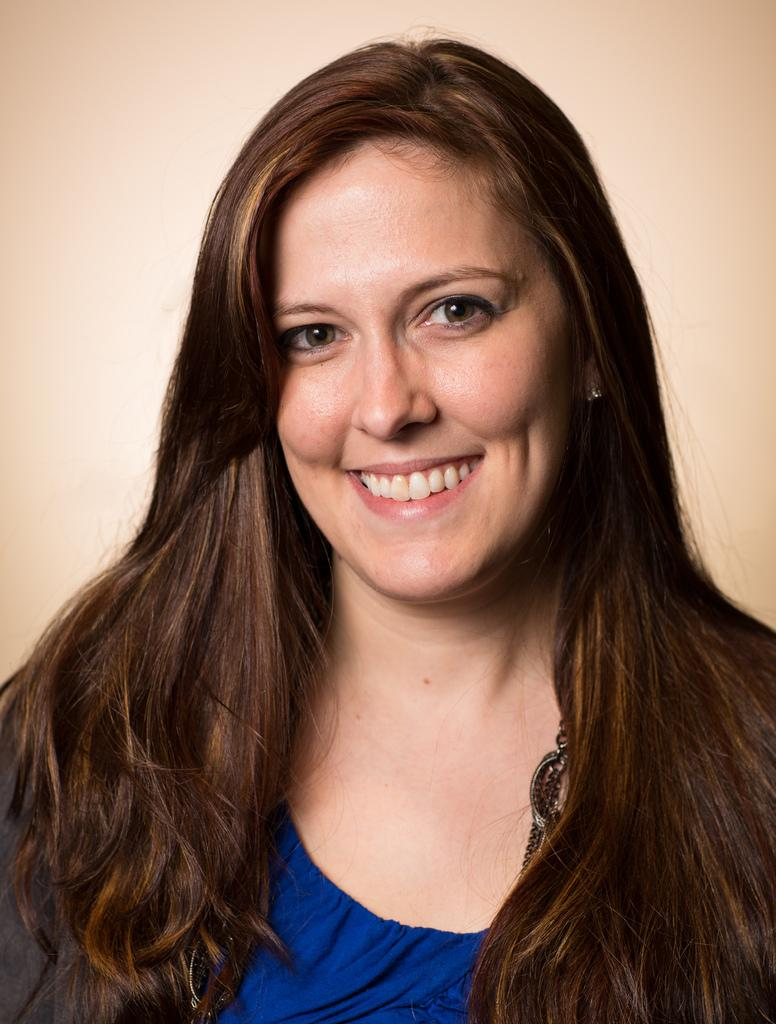Who is present in the image? There is a woman in the image. What expression does the woman have? The woman is smiling. What can be seen in the background of the image? There is a wall in the background of the image. What type of worm can be seen crawling on the wall in the image? There is no worm present in the image; only the woman and the wall are visible. 